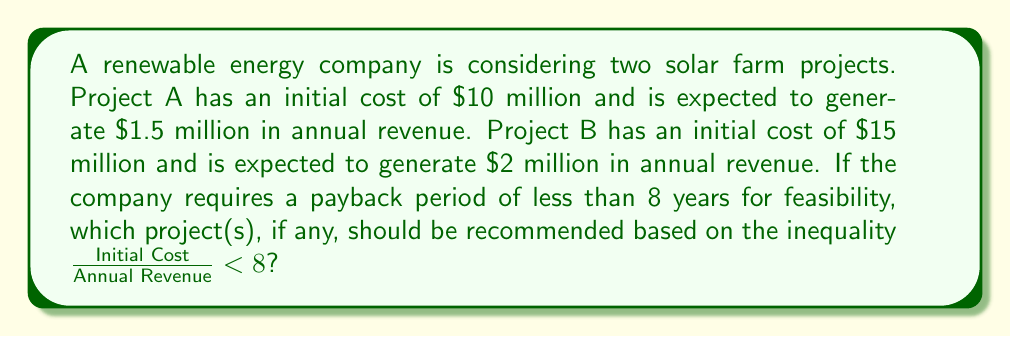Teach me how to tackle this problem. Let's evaluate each project using the given inequality:

1. For Project A:
   Initial Cost = $10 million
   Annual Revenue = $1.5 million
   
   $$\frac{\text{Initial Cost}}{\text{Annual Revenue}} = \frac{10}{1.5} \approx 6.67$$
   
   Since $6.67 < 8$, Project A satisfies the inequality.

2. For Project B:
   Initial Cost = $15 million
   Annual Revenue = $2 million
   
   $$\frac{\text{Initial Cost}}{\text{Annual Revenue}} = \frac{15}{2} = 7.5$$
   
   Since $7.5 < 8$, Project B also satisfies the inequality.

Both projects have a payback period of less than 8 years, making them both feasible according to the given criterion.
Answer: Both Project A and Project B 